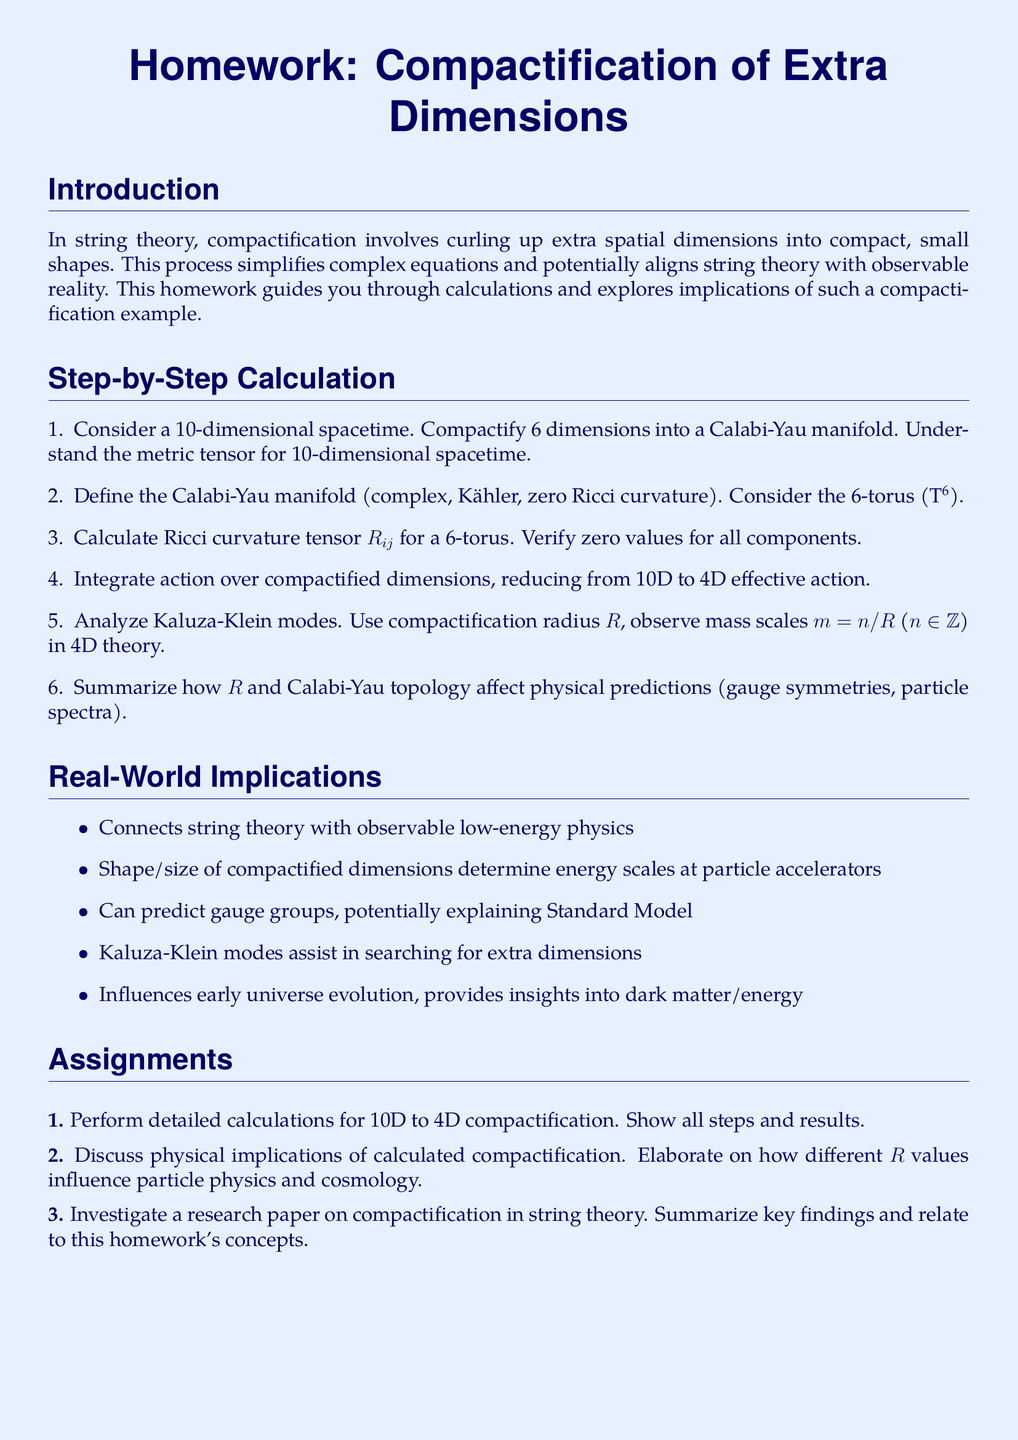What is the main topic of the homework? The homework focuses on the calculations and implications of compactification in string theory.
Answer: Compactification of Extra Dimensions How many dimensions are being compactified? The document states that 6 dimensions are being compactified from a 10-dimensional spacetime.
Answer: 6 dimensions What type of manifold is mentioned for compactification? The homework refers to a Calabi-Yau manifold in the context of compactification.
Answer: Calabi-Yau manifold What is the mass scale formula mentioned in the document? The mass scale in the context of Kaluza-Klein modes is given by the formula m = n/R.
Answer: m = n/R Which curvature type does the Calabi-Yau manifold have? The document mentions that the Calabi-Yau manifold has zero Ricci curvature.
Answer: Zero Ricci curvature What is the effect of the compactification radius on the theory? The compactification radius affects the mass scales of the Kaluza-Klein modes and thereby influences the physical predictions in the 4D theory.
Answer: Influences physical predictions What key topic is assigned in Assignment 3? Assignment 3 asks to investigate a research paper on compactification in string theory.
Answer: Investigate a research paper Name one implication of compactification mentioned in the document. The document lists several implications, one of which is that it can explain gauge groups relevant to the Standard Model.
Answer: Explain gauge groups 